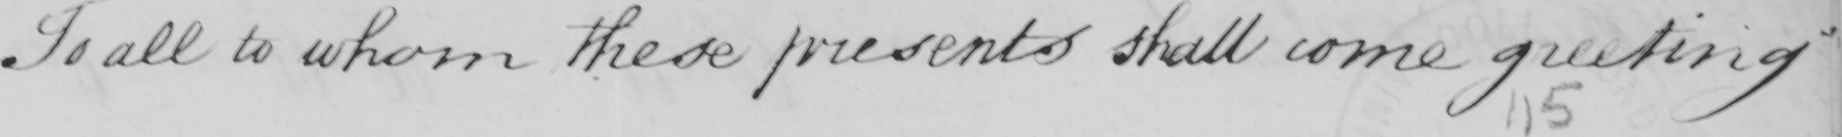What does this handwritten line say? To all to whom these presents shall come greeting 